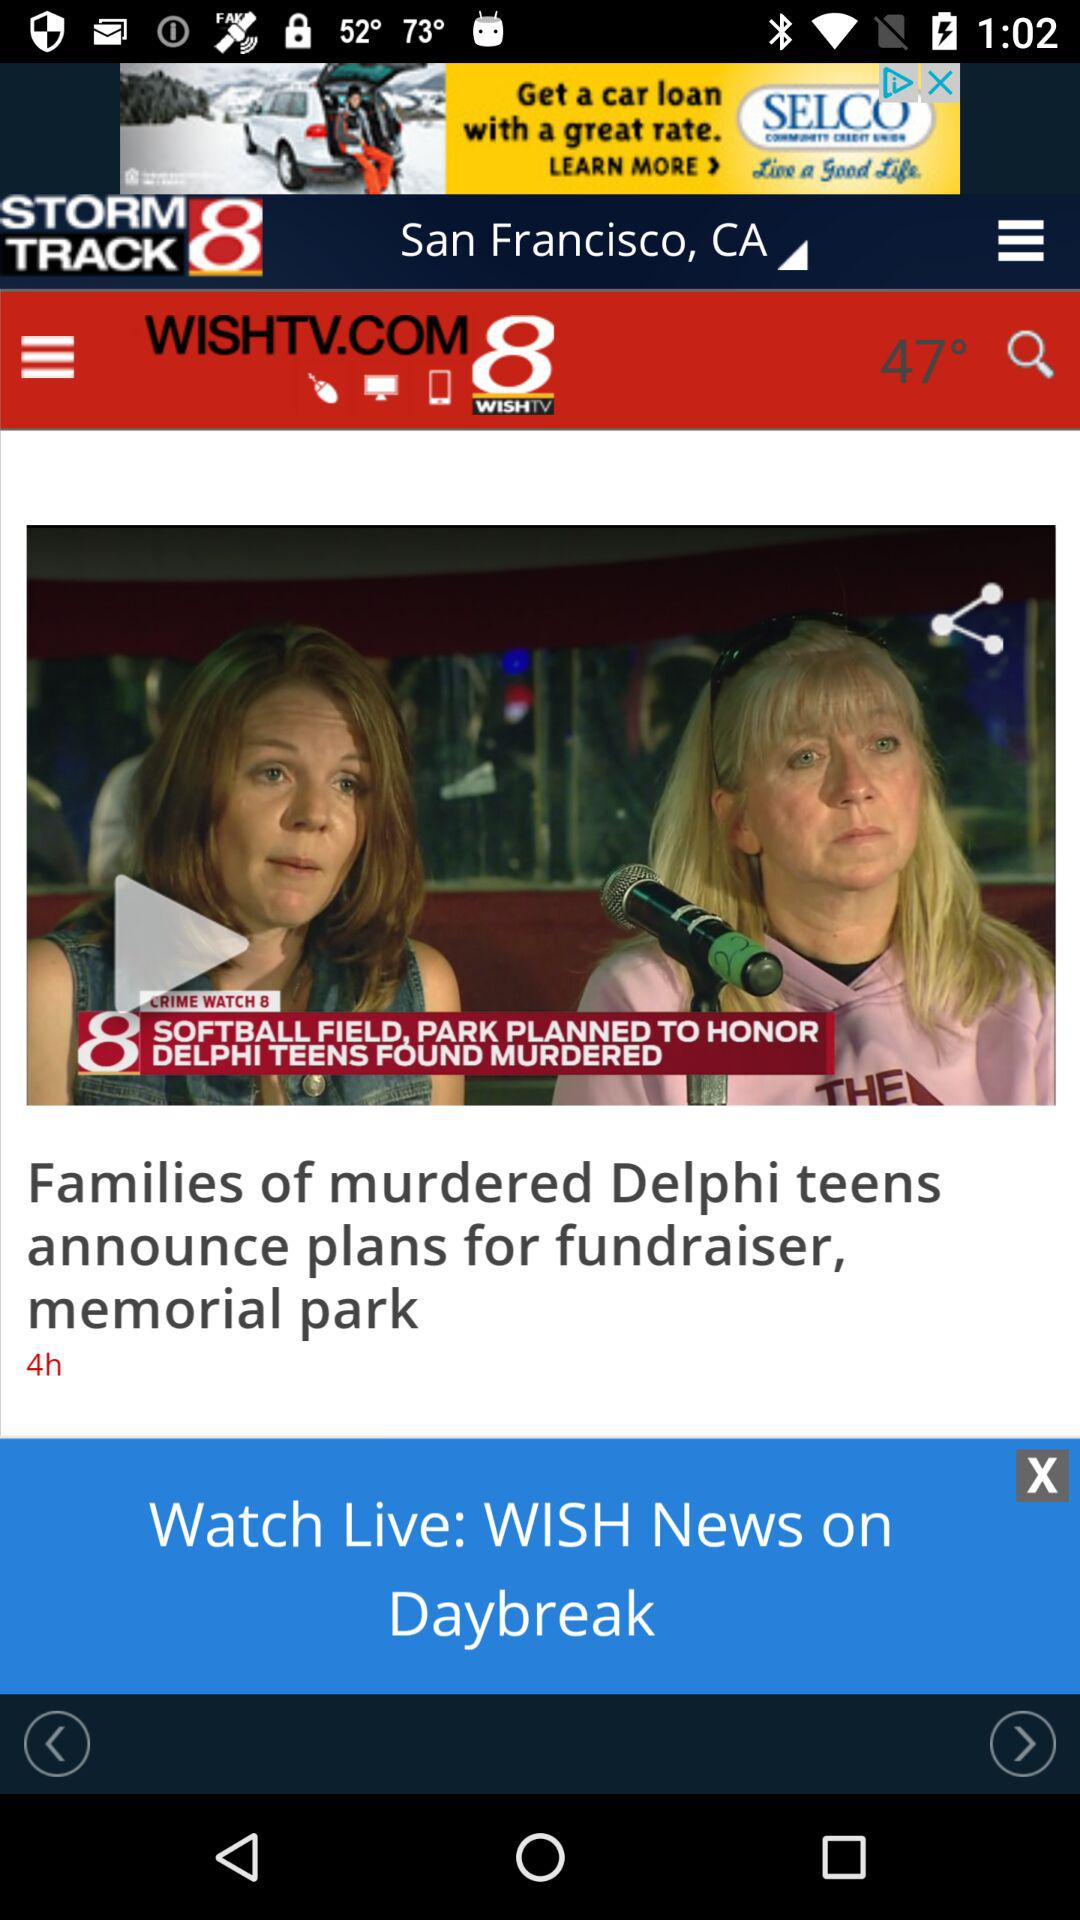Which city is selected? The selected city is San Francisco, CA. 